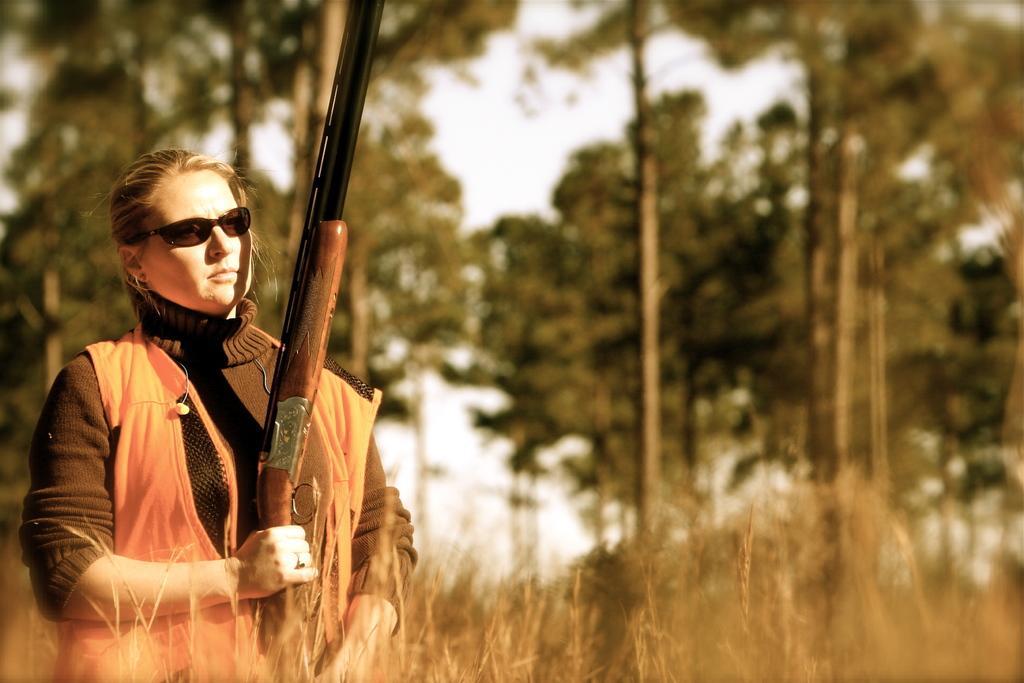Can you describe this image briefly? In this picture we can see a woman, she is holding a gun and in the background we can see trees, sky. 